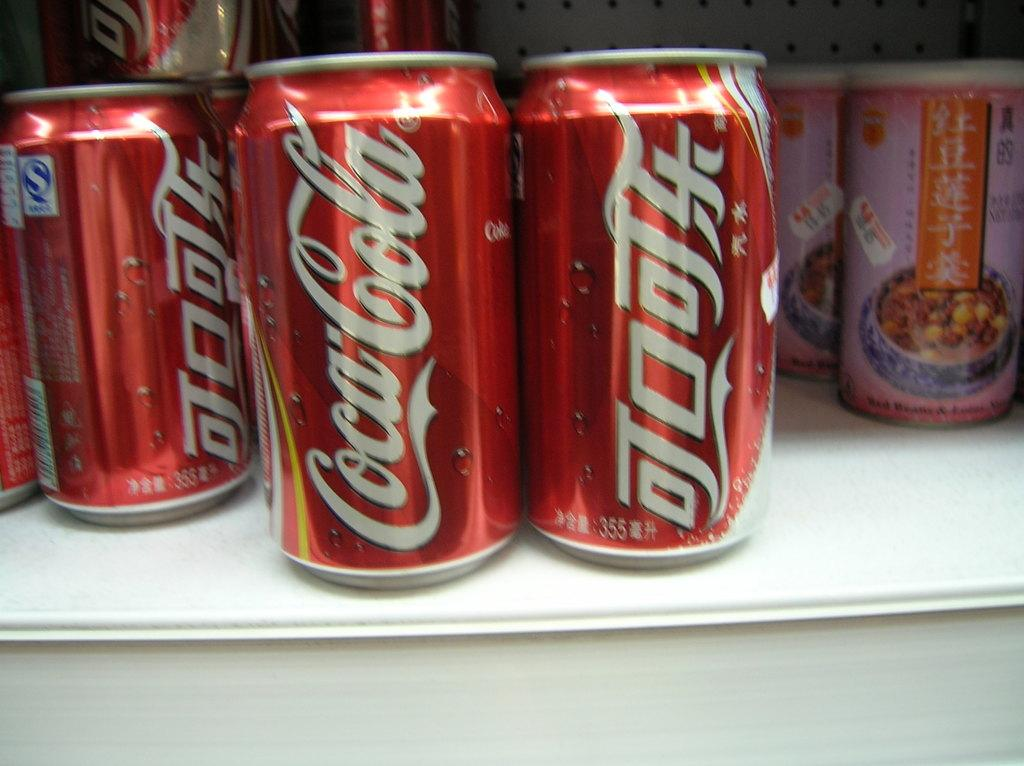What type of beverage containers are present in the image? There are coke tins in the image. What else can be seen on the shelf in the image? There are other items on the shelf in the image. Is there a pest crawling on the coke tins in the image? There is no indication of a pest in the image, as it only shows coke tins and other items on a shelf. 